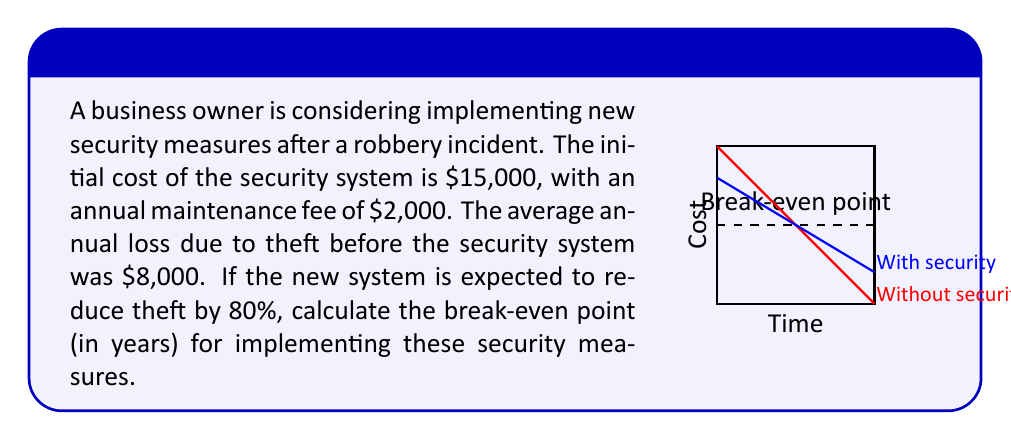Help me with this question. Let's approach this step-by-step:

1) First, let's define our variables:
   $x$ = number of years
   $C(x)$ = total cost with security measures after $x$ years
   $L(x)$ = total losses without security measures after $x$ years

2) We can express $C(x)$ and $L(x)$ as functions:
   $C(x) = 15000 + 2000x + 0.2 \cdot 8000x$
   $L(x) = 8000x$

   The $0.2 \cdot 8000x$ term in $C(x)$ represents the 20% of theft that still occurs with the new system.

3) At the break-even point, these two functions are equal:
   $C(x) = L(x)$

4) Let's solve this equation:
   $15000 + 2000x + 1600x = 8000x$
   $15000 + 3600x = 8000x$
   $15000 = 4400x$

5) Solving for $x$:
   $x = \frac{15000}{4400} = 3.409$

6) Therefore, the break-even point is approximately 3.41 years.
Answer: 3.41 years 